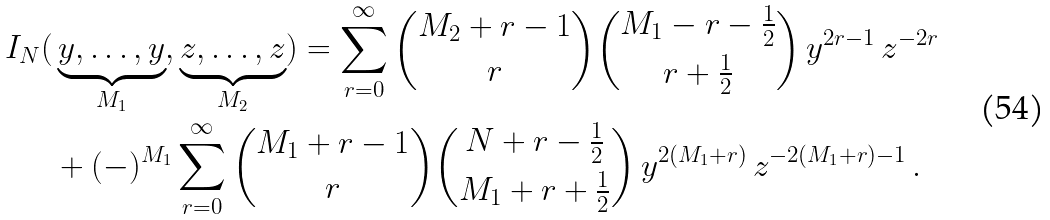<formula> <loc_0><loc_0><loc_500><loc_500>I _ { N } ( & \underbrace { y , \dots , y } _ { M _ { 1 } } , \underbrace { z , \dots , z } _ { M _ { 2 } } ) = \sum _ { r = 0 } ^ { \infty } \binom { M _ { 2 } + r - 1 } { r } \binom { M _ { 1 } - r - \frac { 1 } { 2 } } { r + \frac { 1 } { 2 } } \, y ^ { 2 r - 1 } \, z ^ { - 2 r } \\ & + ( - ) ^ { M _ { 1 } } \sum _ { r = 0 } ^ { \infty } \binom { M _ { 1 } + r - 1 } { r } \binom { N + r - \frac { 1 } { 2 } } { M _ { 1 } + r + \frac { 1 } { 2 } } \, y ^ { 2 ( M _ { 1 } + r ) } \, z ^ { - 2 ( M _ { 1 } + r ) - 1 } \, . \\</formula> 